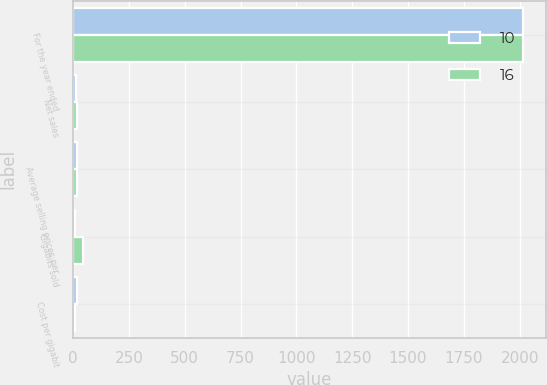Convert chart. <chart><loc_0><loc_0><loc_500><loc_500><stacked_bar_chart><ecel><fcel>For the year ended<fcel>Net sales<fcel>Average selling prices per<fcel>Gigabits sold<fcel>Cost per gigabit<nl><fcel>10<fcel>2016<fcel>14<fcel>20<fcel>8<fcel>16<nl><fcel>16<fcel>2015<fcel>20<fcel>17<fcel>45<fcel>10<nl></chart> 